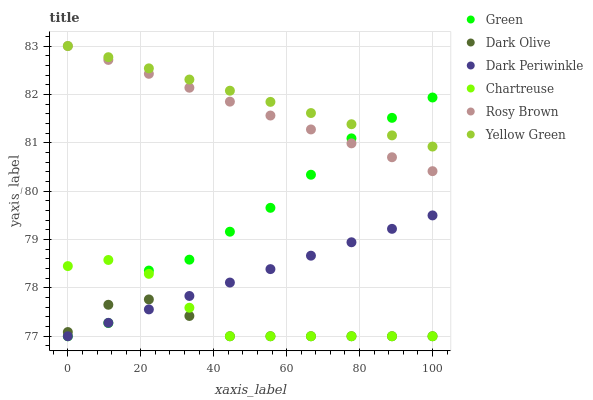Does Dark Olive have the minimum area under the curve?
Answer yes or no. Yes. Does Yellow Green have the maximum area under the curve?
Answer yes or no. Yes. Does Yellow Green have the minimum area under the curve?
Answer yes or no. No. Does Dark Olive have the maximum area under the curve?
Answer yes or no. No. Is Dark Periwinkle the smoothest?
Answer yes or no. Yes. Is Green the roughest?
Answer yes or no. Yes. Is Yellow Green the smoothest?
Answer yes or no. No. Is Yellow Green the roughest?
Answer yes or no. No. Does Dark Olive have the lowest value?
Answer yes or no. Yes. Does Yellow Green have the lowest value?
Answer yes or no. No. Does Yellow Green have the highest value?
Answer yes or no. Yes. Does Dark Olive have the highest value?
Answer yes or no. No. Is Chartreuse less than Rosy Brown?
Answer yes or no. Yes. Is Yellow Green greater than Dark Periwinkle?
Answer yes or no. Yes. Does Green intersect Dark Olive?
Answer yes or no. Yes. Is Green less than Dark Olive?
Answer yes or no. No. Is Green greater than Dark Olive?
Answer yes or no. No. Does Chartreuse intersect Rosy Brown?
Answer yes or no. No. 